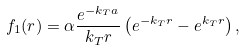Convert formula to latex. <formula><loc_0><loc_0><loc_500><loc_500>f _ { 1 } ( r ) = \alpha \frac { e ^ { - k _ { T } a } } { k _ { T } r } \left ( e ^ { - k _ { T } r } - e ^ { k _ { T } r } \right ) ,</formula> 